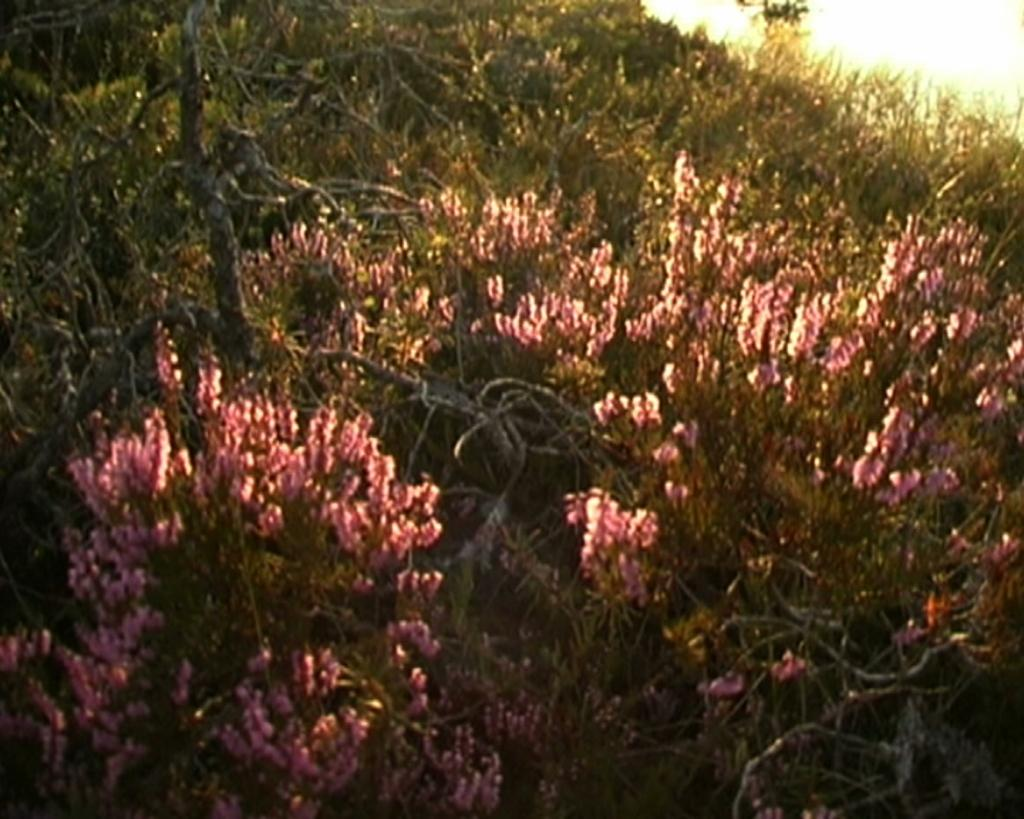What type of living organisms can be seen in the image? There are flowers and plants in the image. Can you describe the plants in the image? The image contains flowers, which are a type of plant. What type of insect can be seen crawling on the farm in the image? There is no farm or insect present in the image; it only contains flowers and plants. 